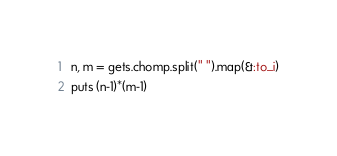Convert code to text. <code><loc_0><loc_0><loc_500><loc_500><_Ruby_>n, m = gets.chomp.split(" ").map(&:to_i)
puts (n-1)*(m-1)</code> 